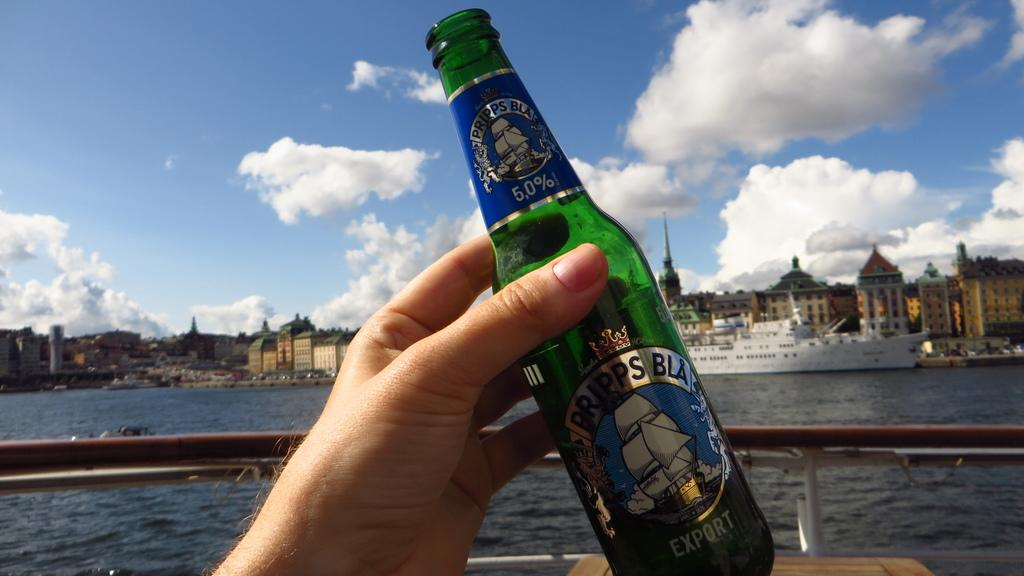What is the human hand holding in the image? The human hand is holding a bottle in the image. What is the name of the bottle? The bottle is named "Export". What can be seen in the sky in the image? Clouds are present in the sky in the image. What is visible in the background of the image? There are buildings in the background of the image. What type of vehicle is present in the image? A ship is visible in the image. What is the primary liquid visible in the image? There is water in the image. What is the weight of the ship in the image? The weight of the ship cannot be determined from the image alone, as it does not provide any information about the size or construction of the ship. 